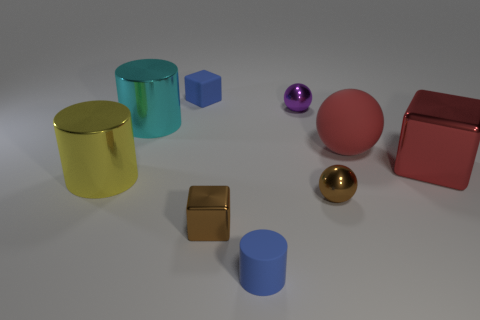What could be the purpose or function of these objects in a real-life setting? In a real-life setting, these objects could serve various decorative or utilitarian purposes. The cylindrical containers could be vases or storage cases. The spheres might be ornamental accents or weighted paperweights. The cubes could function as aesthetically pleasing geometric decor or educational tools to demonstrate shapes and volume.  Imagine these objects were part of an art installation; what kind of theme or message might they convey? Envisioned as part of an art installation, these objects could symbolize the harmony of geometry and color in space. The contrasting shapes and finishes might reflect the diversity in unity, or how different elements can coexist and complement each other to form a balanced and aesthetically pleasing whole. 